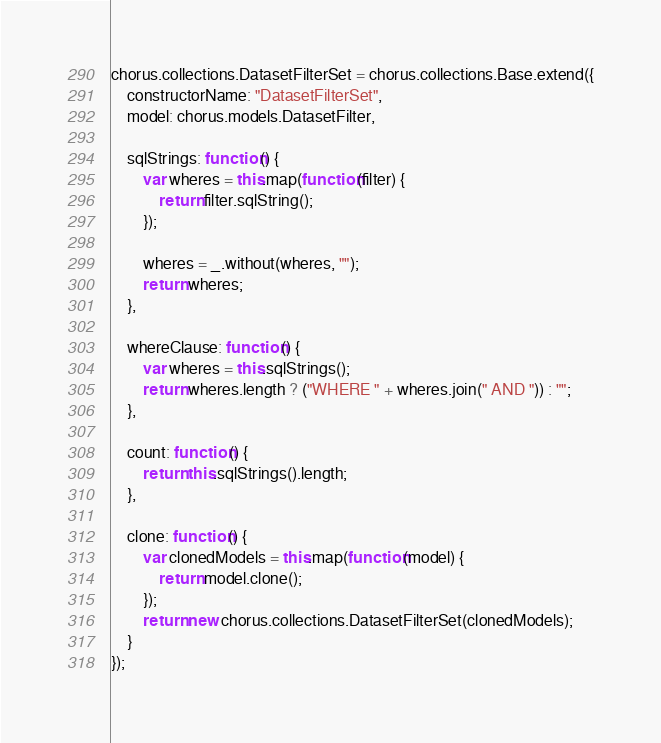Convert code to text. <code><loc_0><loc_0><loc_500><loc_500><_JavaScript_>chorus.collections.DatasetFilterSet = chorus.collections.Base.extend({
    constructorName: "DatasetFilterSet",
    model: chorus.models.DatasetFilter,

    sqlStrings: function() {
        var wheres = this.map(function(filter) {
            return filter.sqlString();
        });

        wheres = _.without(wheres, "");
        return wheres;
    },

    whereClause: function() {
        var wheres = this.sqlStrings();
        return wheres.length ? ("WHERE " + wheres.join(" AND ")) : "";
    },

    count: function() {
        return this.sqlStrings().length;
    },

    clone: function() {
        var clonedModels = this.map(function(model) {
            return model.clone();
        });
        return new chorus.collections.DatasetFilterSet(clonedModels);
    }
});
</code> 